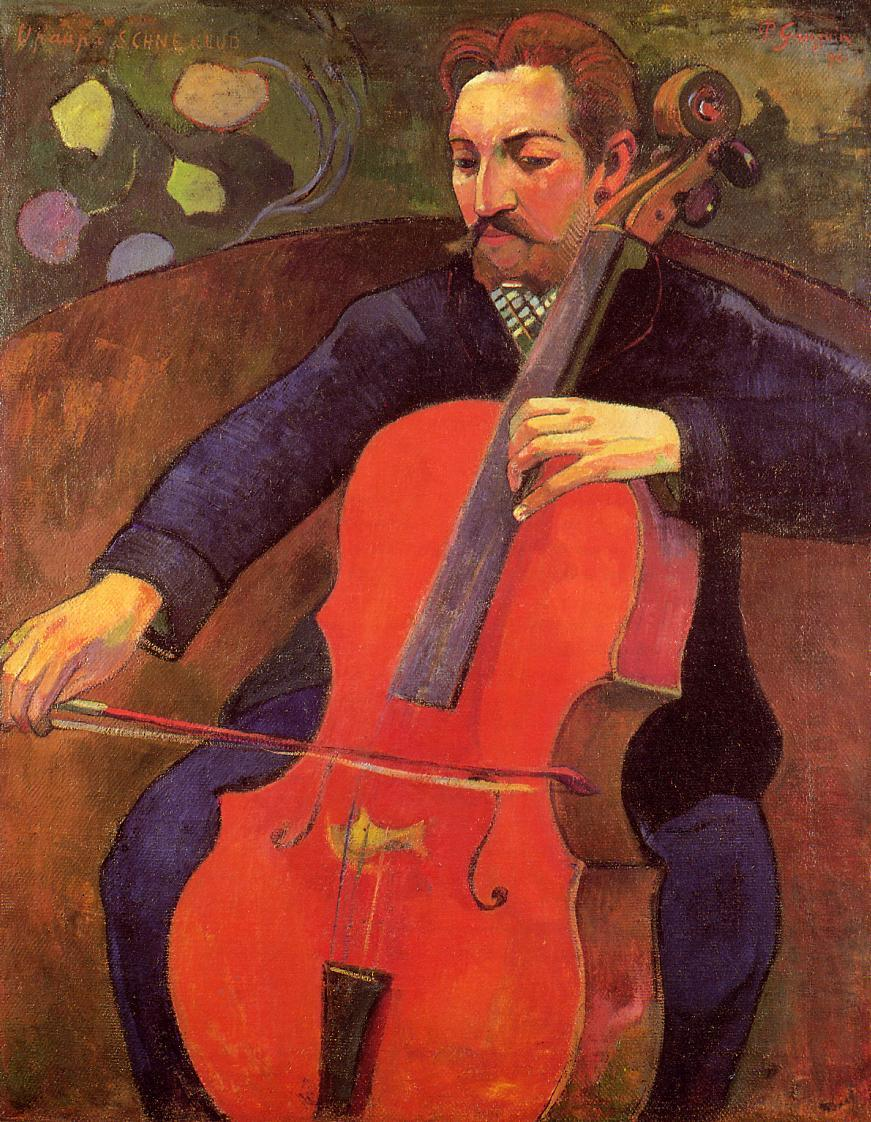What emotions do you think the musician is experiencing in this moment? The musician appears to be experiencing a deep sense of passion and concentration. His closed eyes and the gentle, yet firm grip on the cello suggest that he is fully immersed in the music, possibly lost in a profound state of emotional expression. The serene yet intense expression on his face hints at a blend of joy, serenity, and dedication. Imagine if this painting could come to life, what would happen next? If this painting could come to life, the musician would continue to play his cello, filling the room with soulful melodies. The background, with its swirling colors and abstract shapes, might begin to ripple and dance to the rhythm of the music. The hints of landscape in the corner could transform into a vivid, living scenery, where trees sway gently, and flowers bloom in response to the cello's harmonious notes. The entire scene would pulsate with vibrant energy, creating an atmosphere of pure magic and emotional resonance. Can you make a short script based on this image coming to life? INT. ART GALLERY - NIGHT

The camera pans across a quiet, dimly lit art gallery. The focus shifts to a painting of a cellist, where the brushstrokes begin to shimmer. Slowly, the cellist in the painting moves, playing his instrument.

MUSICIAN (softly, with closed eyes)

(The cello's notes fill the gallery, echoing across the silent walls, awakening the painted world around him.)

As the music swells, the background colors ripple and dance. Trees and flowers bloom in vibrant hues, responding to each note.

The scene expands beyond the painting, transforming the gallery into a living, breathing forest bathed in the golden glow of the music.

FADE OUT. 